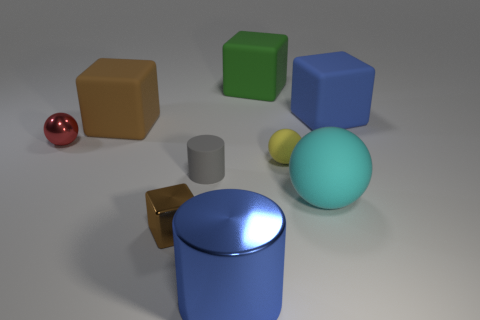What size is the brown metal object that is the same shape as the blue matte thing?
Ensure brevity in your answer.  Small. Does the large blue cube have the same material as the big blue thing that is in front of the blue rubber cube?
Provide a short and direct response. No. What number of things are either large brown rubber things or cylinders?
Make the answer very short. 3. Is the size of the block that is in front of the yellow matte sphere the same as the thing that is in front of the tiny brown block?
Provide a short and direct response. No. What number of blocks are small yellow matte things or tiny shiny things?
Make the answer very short. 1. Are any tiny purple shiny things visible?
Your answer should be compact. No. Are there any other things that are the same shape as the large brown object?
Provide a short and direct response. Yes. Is the large ball the same color as the metal cube?
Make the answer very short. No. How many objects are tiny metallic things that are in front of the red shiny sphere or yellow metallic things?
Your answer should be very brief. 1. What number of tiny yellow things are in front of the rubber sphere that is behind the cylinder behind the cyan object?
Your answer should be compact. 0. 